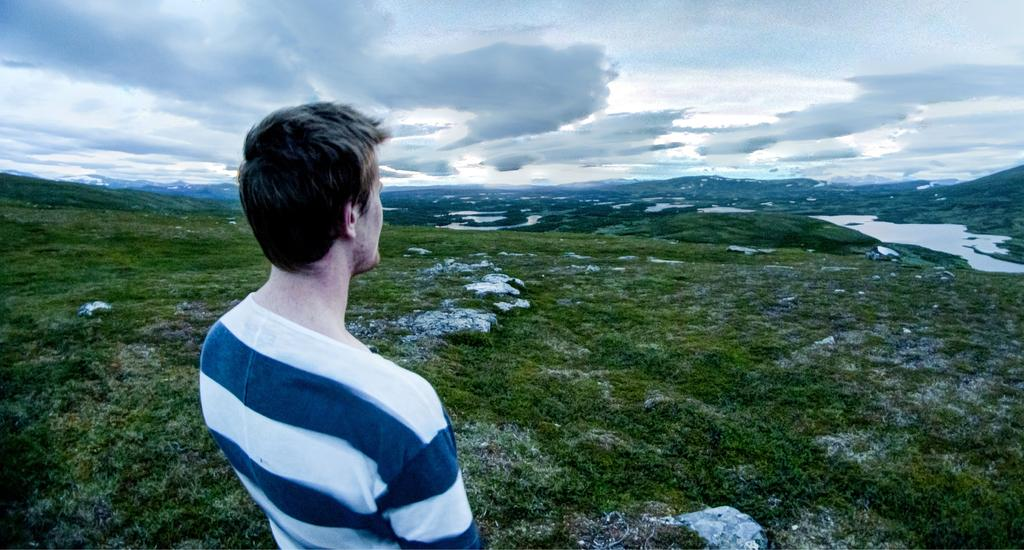Who is the main subject in the image? There is a man in the center of the image. What type of natural environment is visible in the background? There is grass, trees, water, and the sky visible in the background of the image. Can you describe the sky in the image? The sky is visible in the background of the image, and clouds are present. What type of mark can be seen on the bridge in the image? There is no bridge present in the image, so it is not possible to answer that question. 